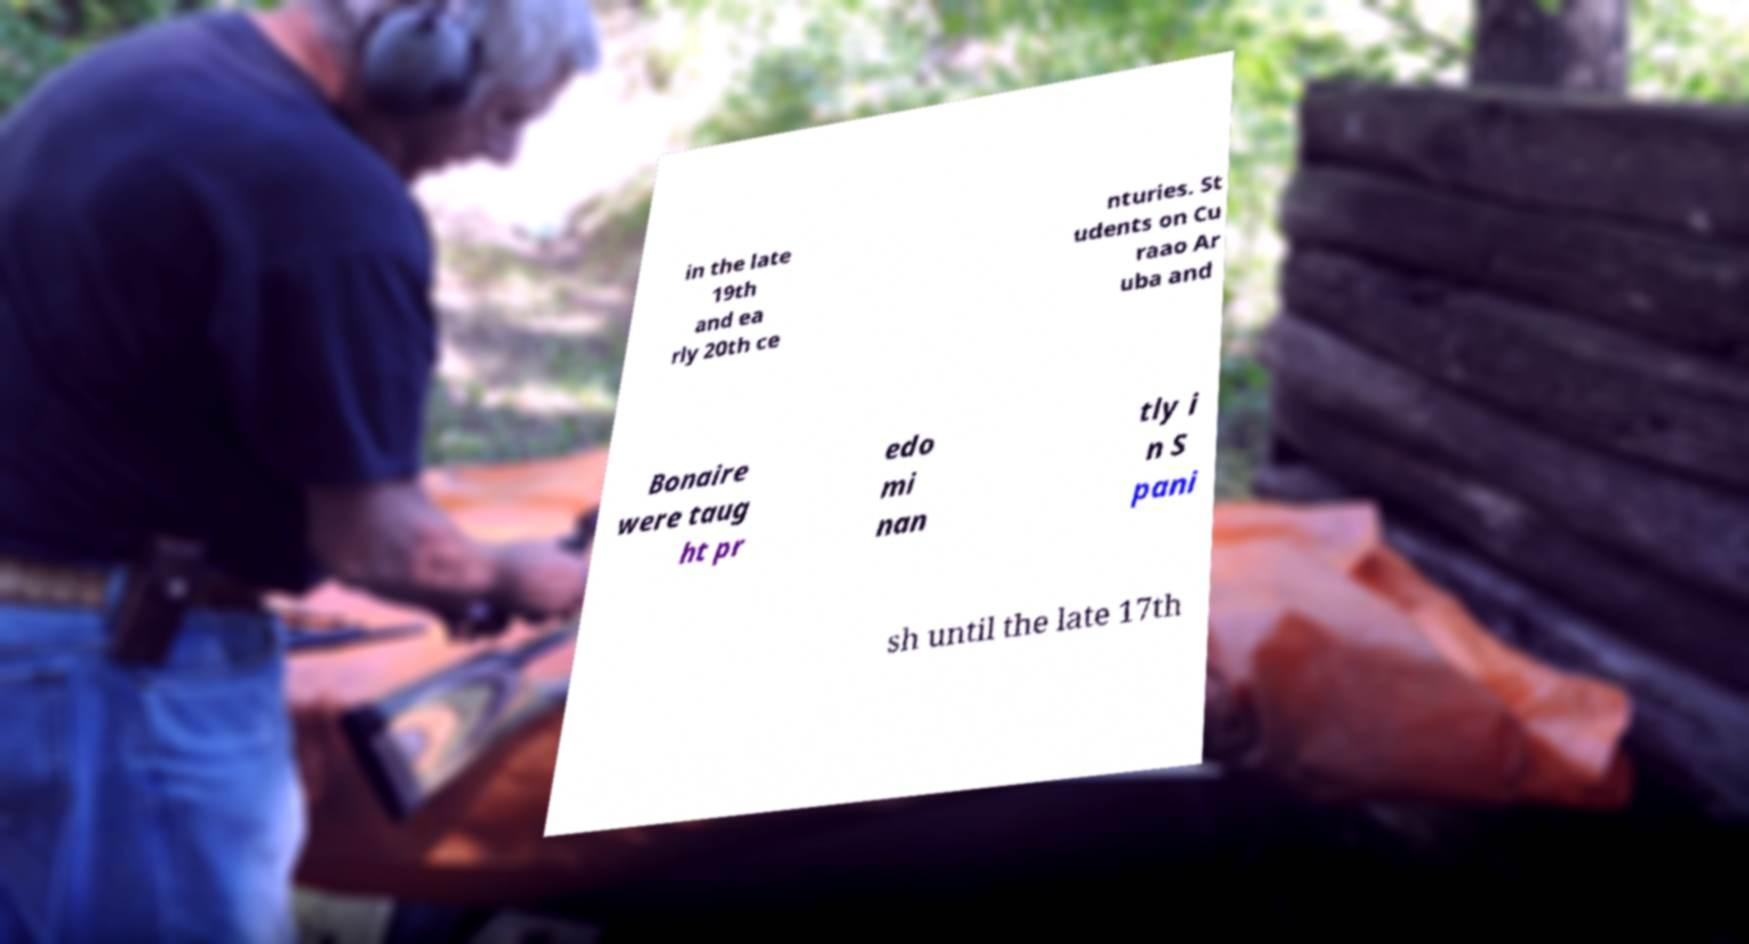I need the written content from this picture converted into text. Can you do that? in the late 19th and ea rly 20th ce nturies. St udents on Cu raao Ar uba and Bonaire were taug ht pr edo mi nan tly i n S pani sh until the late 17th 